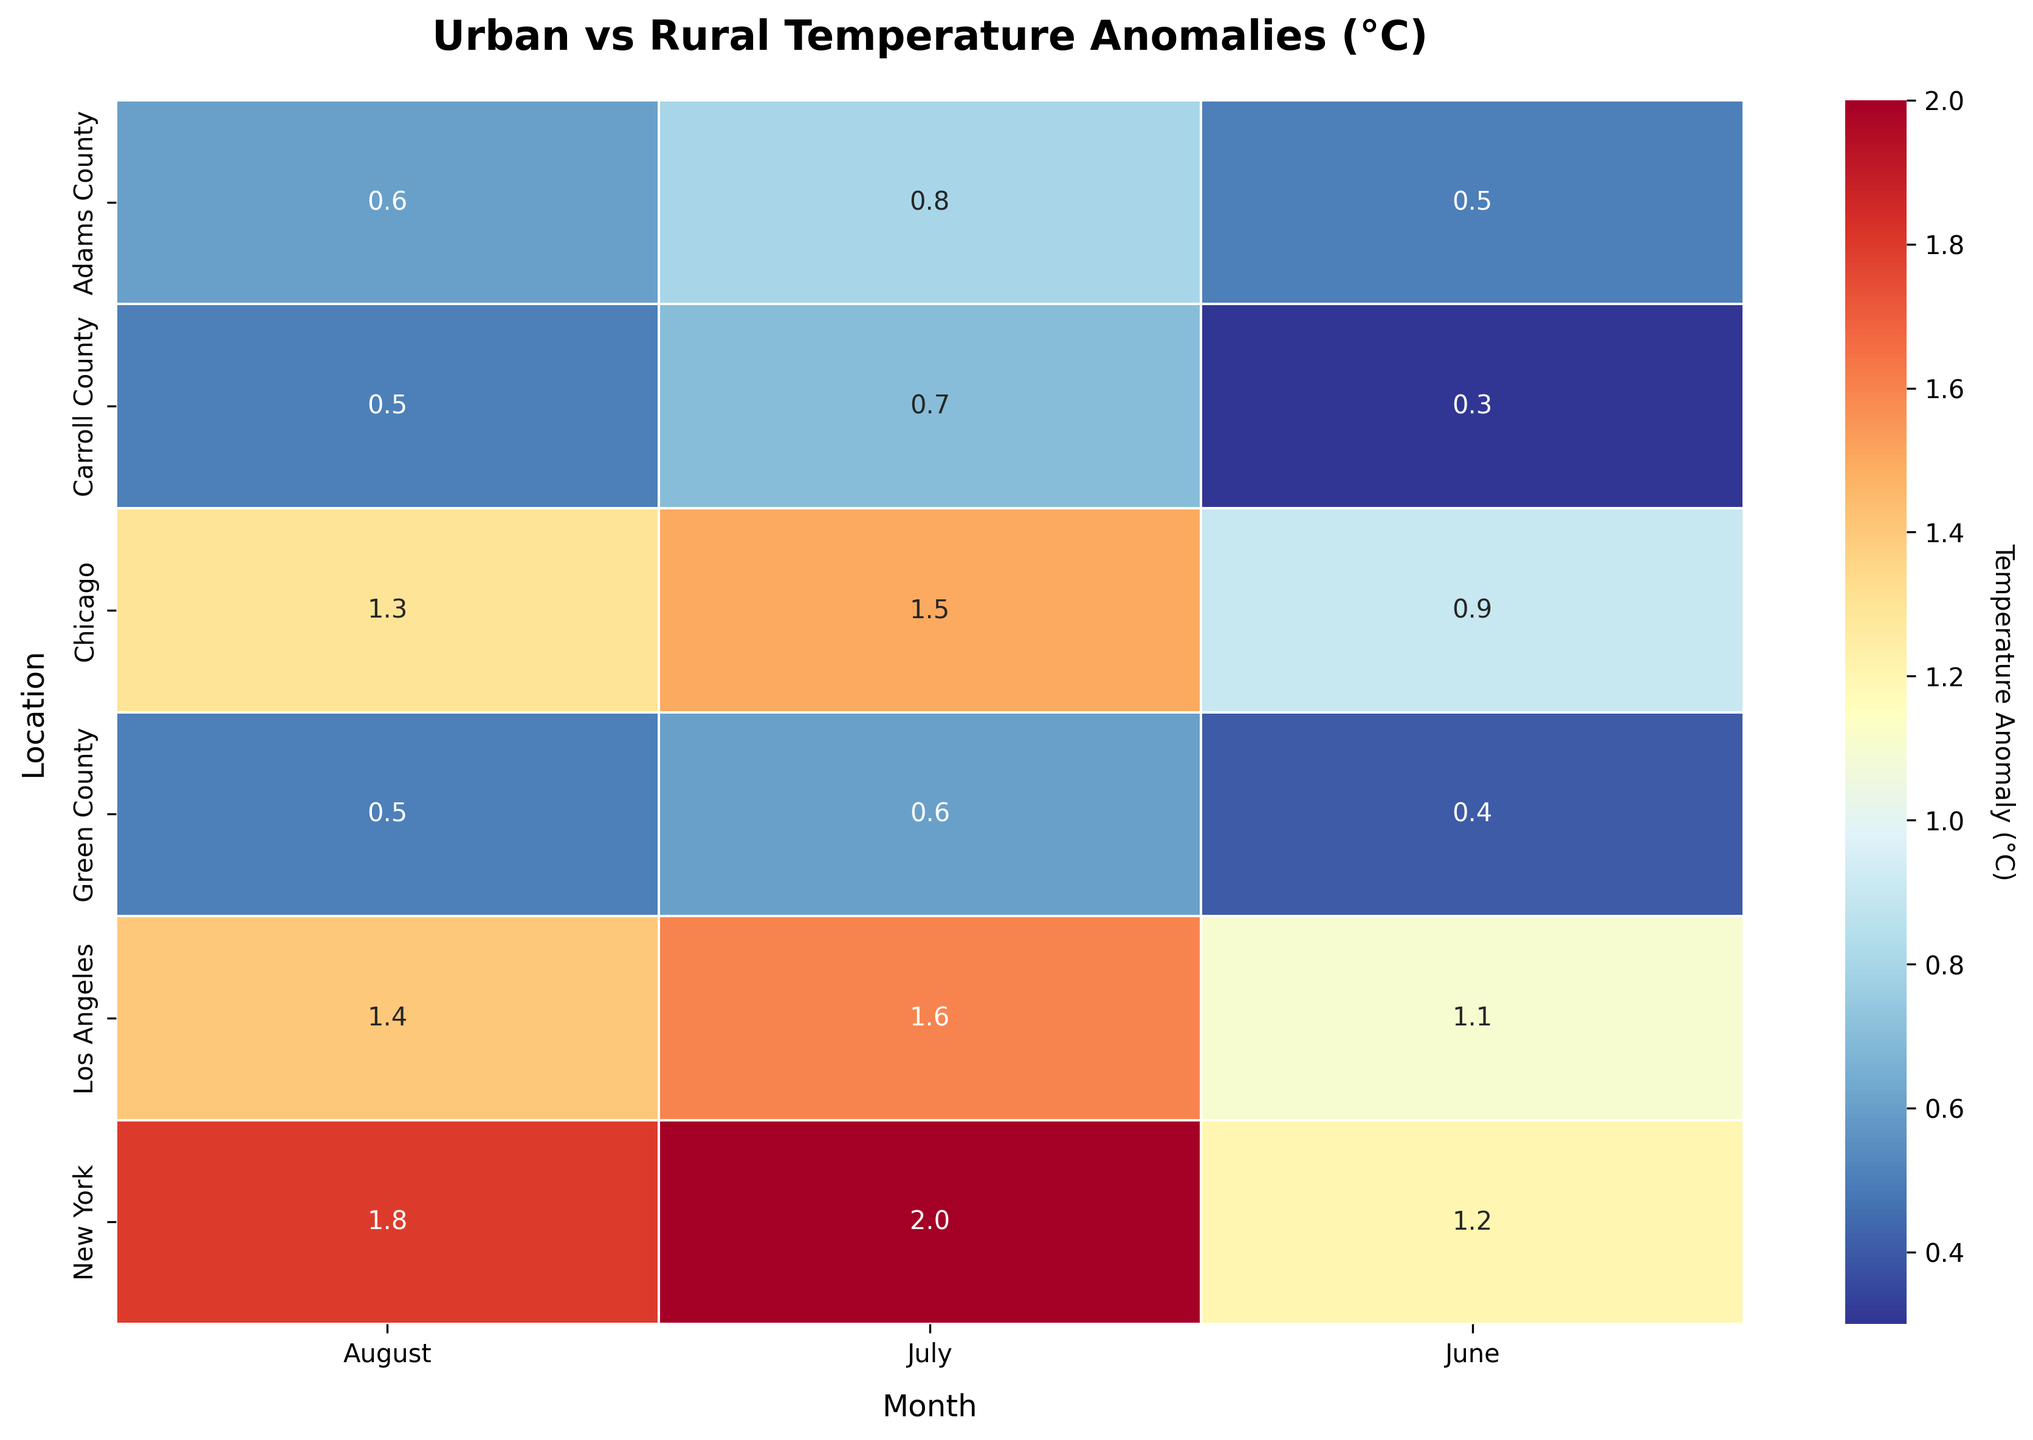What is the highest temperature anomaly for New York in the summer months? Look at the heatmap's row for New York and identify the cells with the highest number. The numbers represent temperature anomalies.
Answer: 2.0 Which location and month combination has the lowest temperature anomaly? Scan through the heatmap to find the smallest number. The smallest number will indicate the location and month for the lowest temperature anomaly.
Answer: Carroll County, June How much higher is the temperature anomaly in Los Angeles in July compared to Chicago in August? Locate the temperature anomaly for Los Angeles in July and for Chicago in August, then subtract the number for Chicago from the number for Los Angeles.
Answer: 0.3 Is the average temperature anomaly in rural areas higher in July or August? Identify the temperature anomalies for all rural locations in both July and August, calculate the averages for each month, and then compare the two averages.
Answer: July Which urban area experienced the smallest temperature anomaly in June? Examine the heatmap's row for urban areas in June and find the smallest value. Note the corresponding location.
Answer: Chicago How do the temperature anomalies in rural areas compare to urban areas during the summer months? Look at the temperature anomalies in the heatmap rows for all rural and urban areas, comparing the values side by side.
Answer: Urban areas generally have higher anomalies What is the difference in the temperature anomaly between Adams County in July and Green County in July? Find the temperature anomalies for both Adams County and Green County in July and calculate the difference by subtracting the smaller value from the larger value.
Answer: 0.2 What is the median temperature anomaly for urban areas in August? Identify the values for all urban areas in August in the heatmap, arrange them in numerical order, and find the middle value.
Answer: 1.4 Which month sees the greatest variation in temperature anomalies for rural areas? For each month, calculate the range of temperature anomalies in rural areas by finding the difference between the maximum and minimum values. Compare these ranges to determine the greatest variation.
Answer: July Does New York or Los Angeles have a higher average temperature anomaly over the summer months? For both New York and Los Angeles, sum up the temperature anomalies for June, July, and August, and divide by 3 to find the average. Compare the two averages.
Answer: New York 